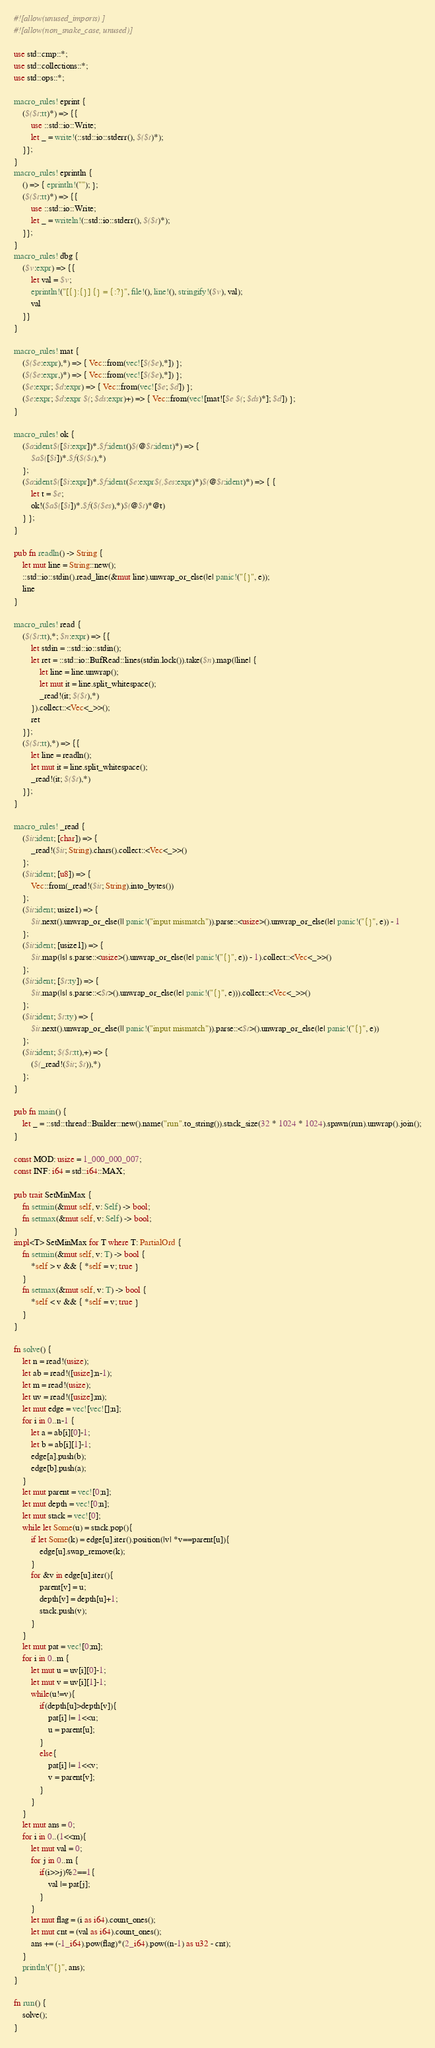Convert code to text. <code><loc_0><loc_0><loc_500><loc_500><_Rust_>#![allow(unused_imports)]
#![allow(non_snake_case, unused)]

use std::cmp::*;
use std::collections::*;
use std::ops::*;

macro_rules! eprint {
	($($t:tt)*) => {{
		use ::std::io::Write;
		let _ = write!(::std::io::stderr(), $($t)*);
	}};
}
macro_rules! eprintln {
	() => { eprintln!(""); };
	($($t:tt)*) => {{
		use ::std::io::Write;
		let _ = writeln!(::std::io::stderr(), $($t)*);
	}};
}
macro_rules! dbg {
	($v:expr) => {{
		let val = $v;
		eprintln!("[{}:{}] {} = {:?}", file!(), line!(), stringify!($v), val);
		val
	}}
}

macro_rules! mat {
	($($e:expr),*) => { Vec::from(vec![$($e),*]) };
	($($e:expr,)*) => { Vec::from(vec![$($e),*]) };
	($e:expr; $d:expr) => { Vec::from(vec![$e; $d]) };
	($e:expr; $d:expr $(; $ds:expr)+) => { Vec::from(vec![mat![$e $(; $ds)*]; $d]) };
}

macro_rules! ok {
	($a:ident$([$i:expr])*.$f:ident()$(@$t:ident)*) => {
		$a$([$i])*.$f($($t),*)
	};
	($a:ident$([$i:expr])*.$f:ident($e:expr$(,$es:expr)*)$(@$t:ident)*) => { {
		let t = $e;
		ok!($a$([$i])*.$f($($es),*)$(@$t)*@t)
	} };
}

pub fn readln() -> String {
	let mut line = String::new();
	::std::io::stdin().read_line(&mut line).unwrap_or_else(|e| panic!("{}", e));
	line
}

macro_rules! read {
	($($t:tt),*; $n:expr) => {{
		let stdin = ::std::io::stdin();
		let ret = ::std::io::BufRead::lines(stdin.lock()).take($n).map(|line| {
			let line = line.unwrap();
			let mut it = line.split_whitespace();
			_read!(it; $($t),*)
		}).collect::<Vec<_>>();
		ret
	}};
	($($t:tt),*) => {{
		let line = readln();
		let mut it = line.split_whitespace();
		_read!(it; $($t),*)
	}};
}

macro_rules! _read {
	($it:ident; [char]) => {
		_read!($it; String).chars().collect::<Vec<_>>()
	};
	($it:ident; [u8]) => {
		Vec::from(_read!($it; String).into_bytes())
	};
	($it:ident; usize1) => {
		$it.next().unwrap_or_else(|| panic!("input mismatch")).parse::<usize>().unwrap_or_else(|e| panic!("{}", e)) - 1
	};
	($it:ident; [usize1]) => {
		$it.map(|s| s.parse::<usize>().unwrap_or_else(|e| panic!("{}", e)) - 1).collect::<Vec<_>>()
	};
	($it:ident; [$t:ty]) => {
		$it.map(|s| s.parse::<$t>().unwrap_or_else(|e| panic!("{}", e))).collect::<Vec<_>>()
	};
	($it:ident; $t:ty) => {
		$it.next().unwrap_or_else(|| panic!("input mismatch")).parse::<$t>().unwrap_or_else(|e| panic!("{}", e))
	};
	($it:ident; $($t:tt),+) => {
		($(_read!($it; $t)),*)
	};
}

pub fn main() {
	let _ = ::std::thread::Builder::new().name("run".to_string()).stack_size(32 * 1024 * 1024).spawn(run).unwrap().join();
}

const MOD: usize = 1_000_000_007;
const INF: i64 = std::i64::MAX;

pub trait SetMinMax {
	fn setmin(&mut self, v: Self) -> bool;
	fn setmax(&mut self, v: Self) -> bool;
}
impl<T> SetMinMax for T where T: PartialOrd {
	fn setmin(&mut self, v: T) -> bool {
		*self > v && { *self = v; true }
	}
	fn setmax(&mut self, v: T) -> bool {
		*self < v && { *self = v; true }
	}
}

fn solve() {
	let n = read!(usize);
	let ab = read!([usize];n-1);
	let m = read!(usize);
	let uv = read!([usize];m);
	let mut edge = vec![vec![];n];
	for i in 0..n-1 {
		let a = ab[i][0]-1;
		let b = ab[i][1]-1;
		edge[a].push(b);
		edge[b].push(a);
	}
	let mut parent = vec![0;n];
	let mut depth = vec![0;n];
	let mut stack = vec![0];
	while let Some(u) = stack.pop(){
		if let Some(k) = edge[u].iter().position(|v| *v==parent[u]){
			edge[u].swap_remove(k);
		}
		for &v in edge[u].iter(){
			parent[v] = u;
			depth[v] = depth[u]+1;
			stack.push(v);
		}
	}
	let mut pat = vec![0;m];
	for i in 0..m {
		let mut u = uv[i][0]-1;
		let mut v = uv[i][1]-1;
		while(u!=v){
			if(depth[u]>depth[v]){
				pat[i] |= 1<<u;
				u = parent[u];
			}
			else{
				pat[i] |= 1<<v;
				v = parent[v];
			}
		}
	}
	let mut ans = 0;
	for i in 0..(1<<m){
		let mut val = 0;
		for j in 0..m {
			if(i>>j)%2==1{
				val |= pat[j];
			}
		}
		let mut flag = (i as i64).count_ones();
		let mut cnt = (val as i64).count_ones();
		ans += (-1_i64).pow(flag)*(2_i64).pow((n-1) as u32 - cnt);
	}
	println!("{}", ans);
}

fn run() {
    solve();
}</code> 